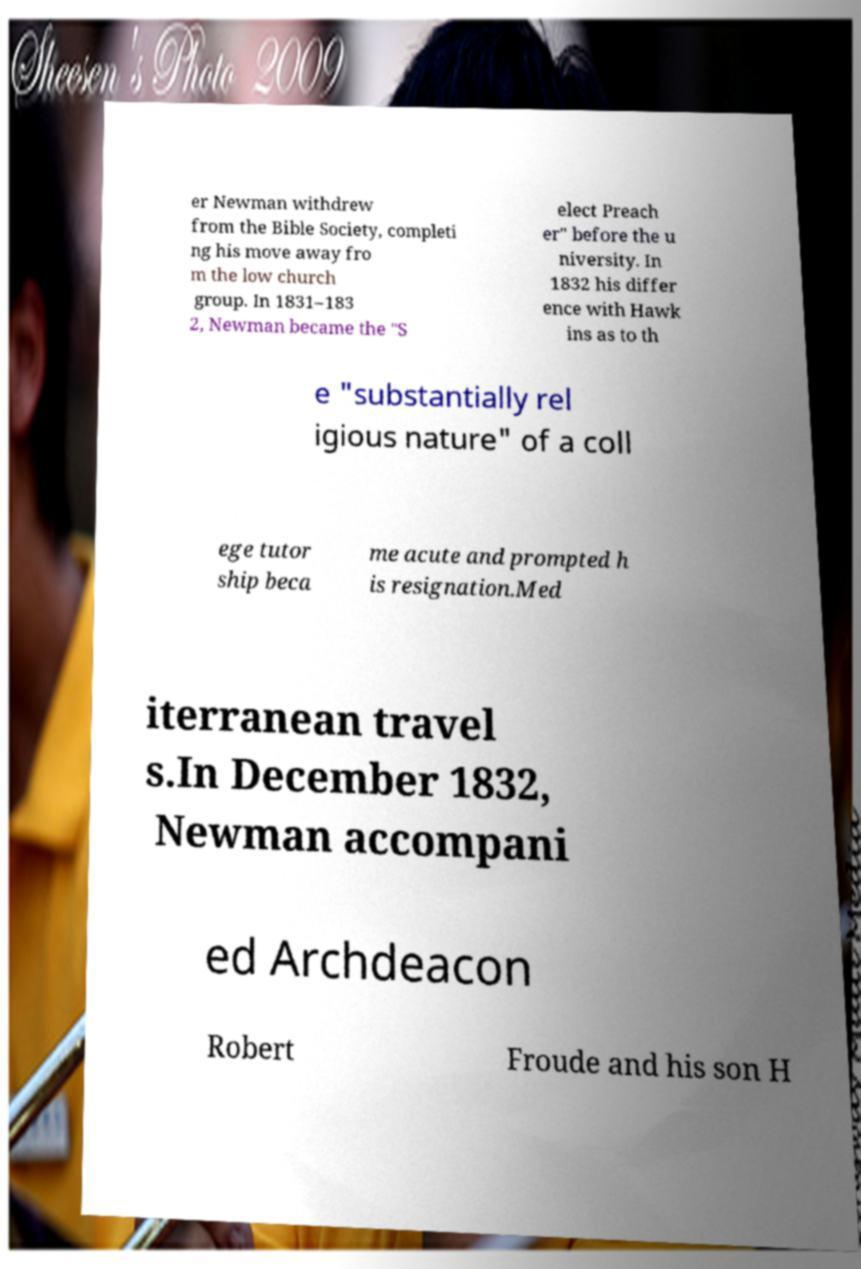Can you read and provide the text displayed in the image?This photo seems to have some interesting text. Can you extract and type it out for me? er Newman withdrew from the Bible Society, completi ng his move away fro m the low church group. In 1831–183 2, Newman became the "S elect Preach er" before the u niversity. In 1832 his differ ence with Hawk ins as to th e "substantially rel igious nature" of a coll ege tutor ship beca me acute and prompted h is resignation.Med iterranean travel s.In December 1832, Newman accompani ed Archdeacon Robert Froude and his son H 